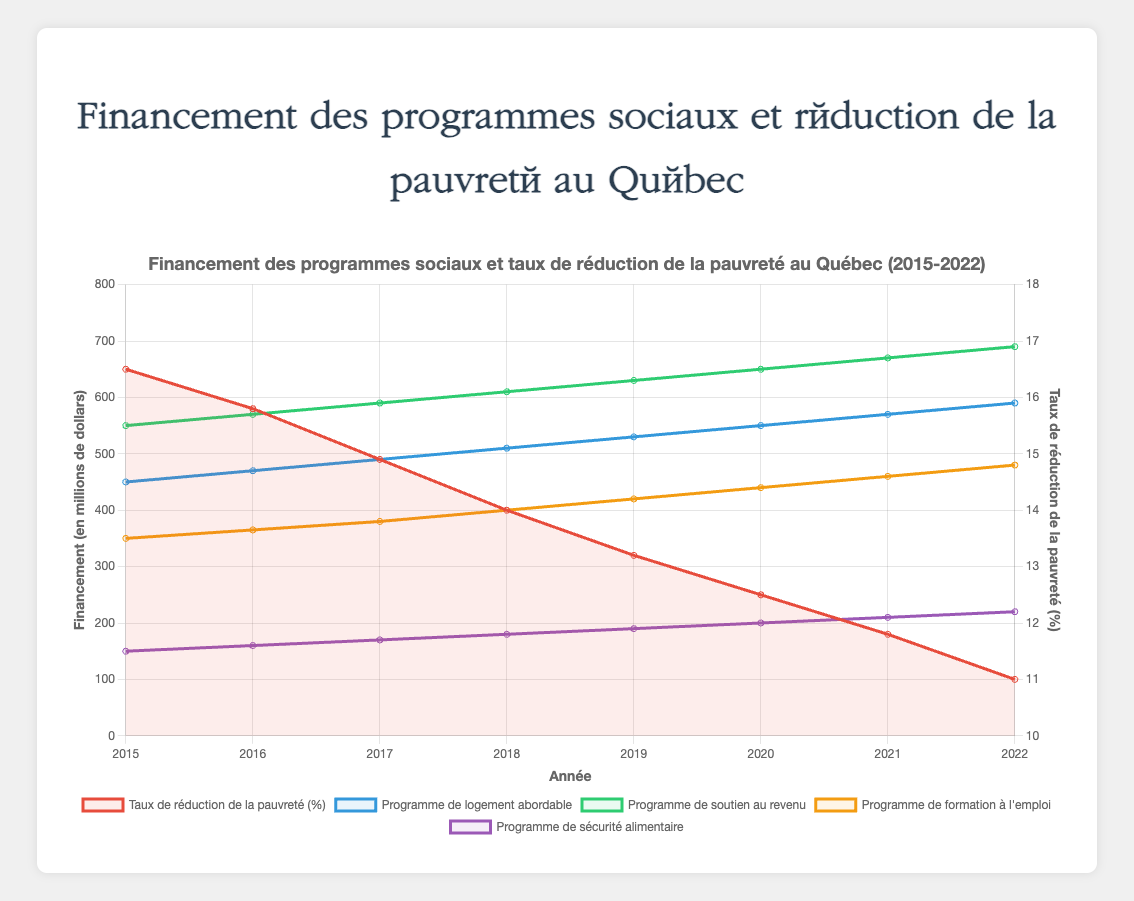Quels sont les montants de financement des différents programmes sociaux en 2015 ? Regardons les valeurs en 2015 pour chaque programme : Programme de logement abordable (450 M$), Programme de soutien au revenu (550 M$), Programme de formation à l'emploi (350 M$), et Programme de sécurité alimentaire (150 M$).
Answer: 450 M$, 550 M$, 350 M$, 150 M$ Quel programme social a reçu le plus de financement en 2020 ? Le financement du Programme de soutien au revenu en 2020 est de 650 M$, ce qui est le plus élevé parmi les programmes.
Answer: Programme de soutien au revenu Comment le taux de réduction de la pauvreté a-t-il évolué de 2015 à 2022 ? Le taux de réduction de la pauvreté a diminué de 16.5% en 2015 à 11.0% en 2022.
Answer: Diminué de 16.5% à 11.0% Quel est l'écart de financement entre le Programme de logement abordable et le Programme de formation à l'emploi en 2019 ? En 2019, le Programme de logement abordable est financé à 530 M$ et le Programme de formation à l'emploi à 420 M$. L'écart est de 530 - 420 = 110 M$.
Answer: 110 M$ Le financement du Programme de sécurité alimentaire augmente-t-il régulièrement chaque année ? Oui, le financement passe de 150 M$ en 2015 à 220 M$ en 2022, augmentant chaque année.
Answer: Oui Quel est le taux moyen de réduction de la pauvreté de 2015 à 2022 ? Sommation des taux de réduction de la pauvreté de 2015 à 2022 : 16.5 + 15.8 + 14.9 + 14.0 + 13.2 + 12.5 + 11.8 + 11.0 = 109.7. Divisons 109.7 par 8 (années) : 109.7 / 8 = 13.71%.
Answer: 13.71% En quelle année le Programme de soutien au revenu a-t-il atteint 650 M$ de financement ? Le Programme de soutien au revenu a atteint 650 M$ en 2020.
Answer: 2020 Les taux de réduction de la pauvreté et les financements du Programme de logement abordable sont-ils toujours en corrélation positive ? En observant les données de 2015 à 2022, à chaque augmentation de financement du Programme de logement abordable, le taux de réduction de la pauvreté diminue, indiquant une corrélation négative.
Answer: Non Quels programmes sociaux ont montré une tendance d'augmentation de leur financement chaque année ? Tous les programmes (Programme de logement abordable, Programme de soutien au revenu, Programme de formation à l'emploi, et Programme de sécurité alimentaire) montrent une tendance à l'augmentation chaque année.
Answer: Tous les programmes 